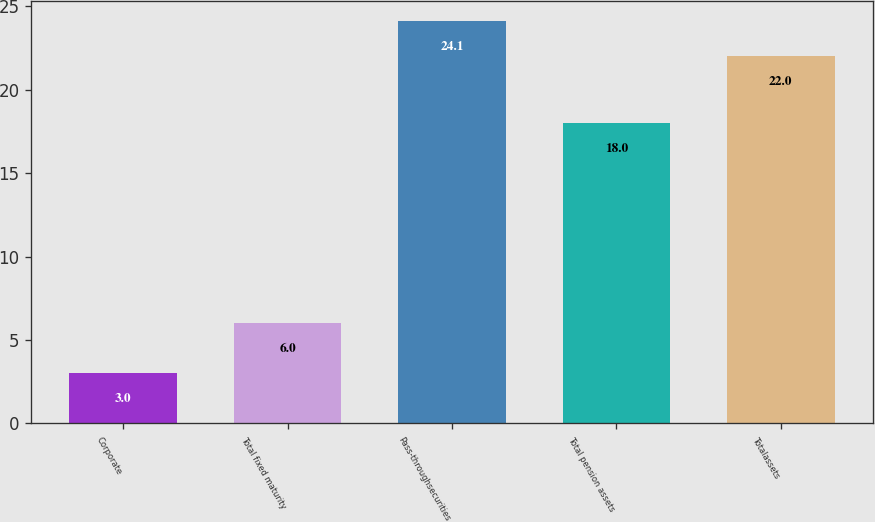<chart> <loc_0><loc_0><loc_500><loc_500><bar_chart><fcel>Corporate<fcel>Total fixed maturity<fcel>Pass-throughsecurities<fcel>Total pension assets<fcel>Totalassets<nl><fcel>3<fcel>6<fcel>24.1<fcel>18<fcel>22<nl></chart> 